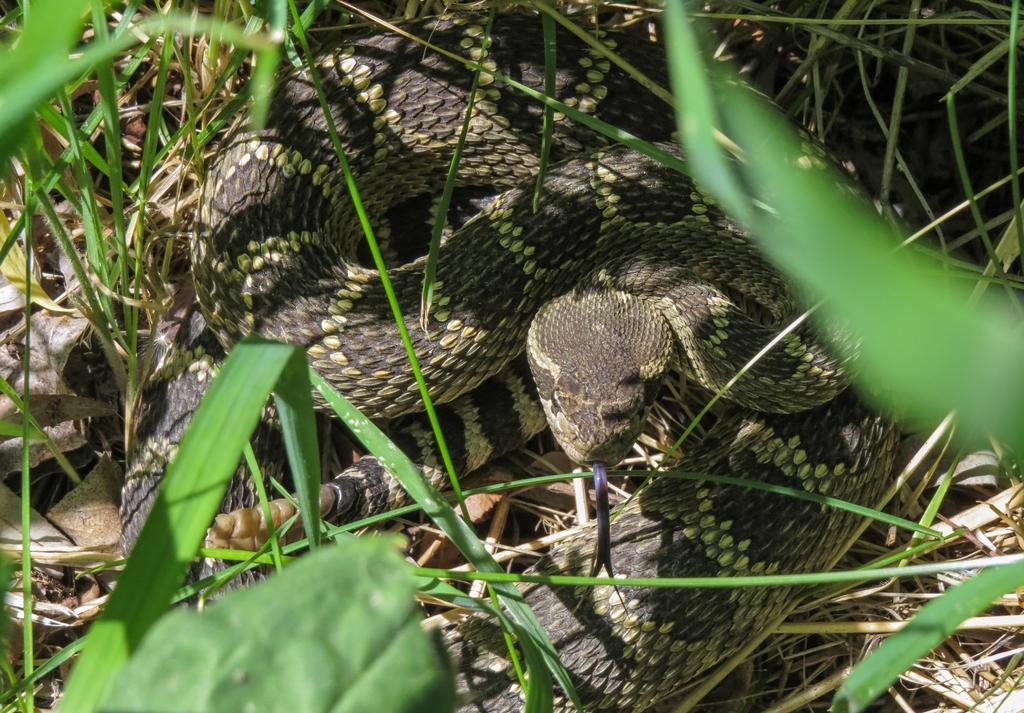Could you give a brief overview of what you see in this image? In the center of the image we can see a snake. In the background of the image we can see the grass and some dry leaves. 